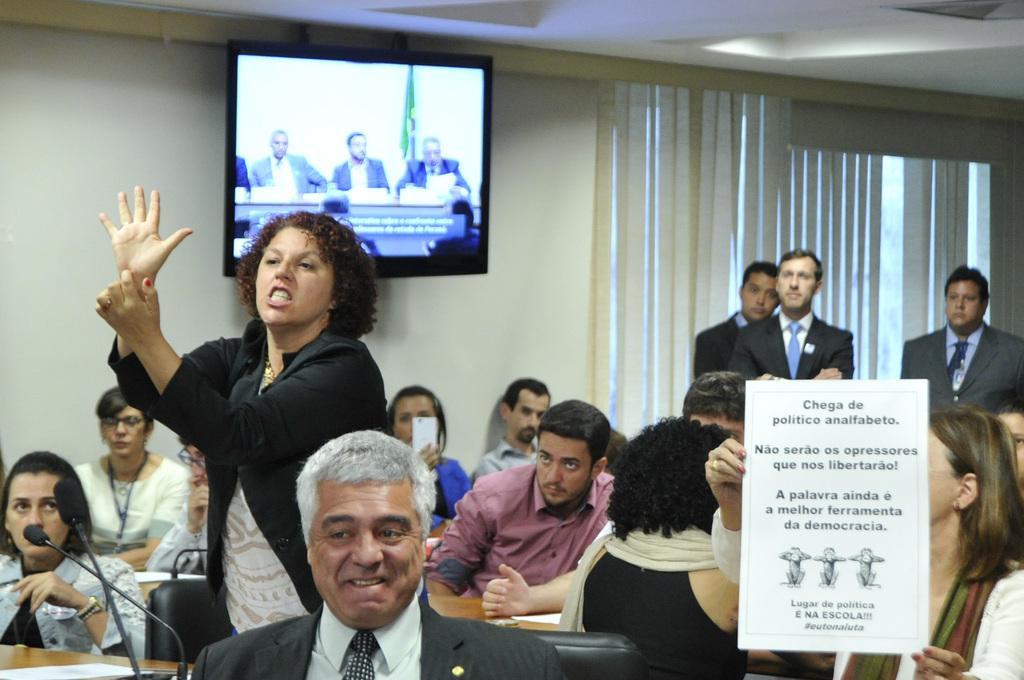Describe this image in one or two sentences. In this image we can see a few people, some of them are standing, a lady is holding a placard with some texts and images on it, there are some chairs, mics, a TV screen on the wall, also we can see the ceiling, window and the curtain. 